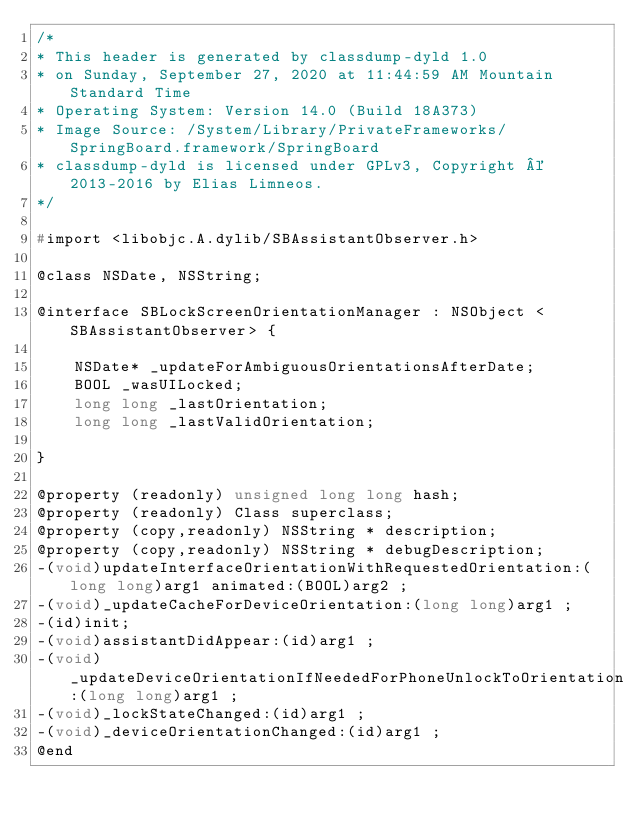Convert code to text. <code><loc_0><loc_0><loc_500><loc_500><_C_>/*
* This header is generated by classdump-dyld 1.0
* on Sunday, September 27, 2020 at 11:44:59 AM Mountain Standard Time
* Operating System: Version 14.0 (Build 18A373)
* Image Source: /System/Library/PrivateFrameworks/SpringBoard.framework/SpringBoard
* classdump-dyld is licensed under GPLv3, Copyright © 2013-2016 by Elias Limneos.
*/

#import <libobjc.A.dylib/SBAssistantObserver.h>

@class NSDate, NSString;

@interface SBLockScreenOrientationManager : NSObject <SBAssistantObserver> {

	NSDate* _updateForAmbiguousOrientationsAfterDate;
	BOOL _wasUILocked;
	long long _lastOrientation;
	long long _lastValidOrientation;

}

@property (readonly) unsigned long long hash; 
@property (readonly) Class superclass; 
@property (copy,readonly) NSString * description; 
@property (copy,readonly) NSString * debugDescription; 
-(void)updateInterfaceOrientationWithRequestedOrientation:(long long)arg1 animated:(BOOL)arg2 ;
-(void)_updateCacheForDeviceOrientation:(long long)arg1 ;
-(id)init;
-(void)assistantDidAppear:(id)arg1 ;
-(void)_updateDeviceOrientationIfNeededForPhoneUnlockToOrientation:(long long)arg1 ;
-(void)_lockStateChanged:(id)arg1 ;
-(void)_deviceOrientationChanged:(id)arg1 ;
@end

</code> 